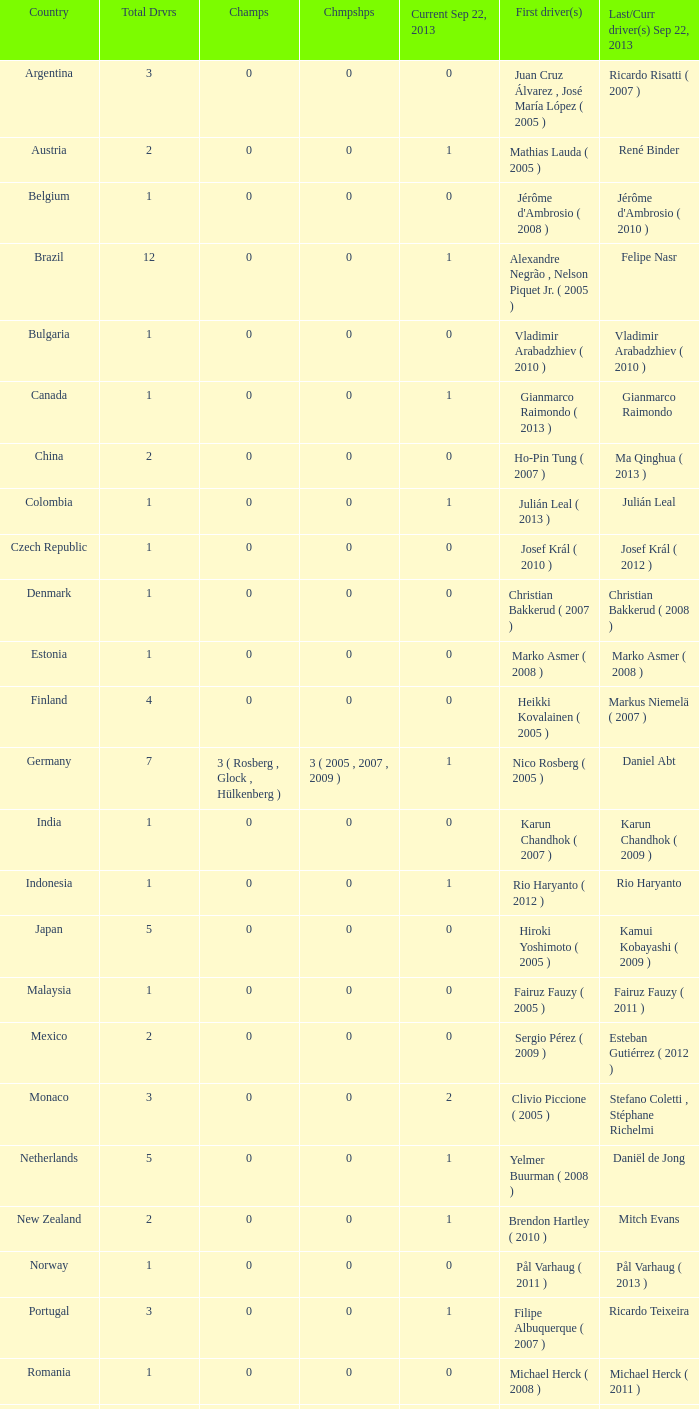Can you parse all the data within this table? {'header': ['Country', 'Total Drvrs', 'Champs', 'Chmpshps', 'Current Sep 22, 2013', 'First driver(s)', 'Last/Curr driver(s) Sep 22, 2013'], 'rows': [['Argentina', '3', '0', '0', '0', 'Juan Cruz Álvarez , José María López ( 2005 )', 'Ricardo Risatti ( 2007 )'], ['Austria', '2', '0', '0', '1', 'Mathias Lauda ( 2005 )', 'René Binder'], ['Belgium', '1', '0', '0', '0', "Jérôme d'Ambrosio ( 2008 )", "Jérôme d'Ambrosio ( 2010 )"], ['Brazil', '12', '0', '0', '1', 'Alexandre Negrão , Nelson Piquet Jr. ( 2005 )', 'Felipe Nasr'], ['Bulgaria', '1', '0', '0', '0', 'Vladimir Arabadzhiev ( 2010 )', 'Vladimir Arabadzhiev ( 2010 )'], ['Canada', '1', '0', '0', '1', 'Gianmarco Raimondo ( 2013 )', 'Gianmarco Raimondo'], ['China', '2', '0', '0', '0', 'Ho-Pin Tung ( 2007 )', 'Ma Qinghua ( 2013 )'], ['Colombia', '1', '0', '0', '1', 'Julián Leal ( 2013 )', 'Julián Leal'], ['Czech Republic', '1', '0', '0', '0', 'Josef Král ( 2010 )', 'Josef Král ( 2012 )'], ['Denmark', '1', '0', '0', '0', 'Christian Bakkerud ( 2007 )', 'Christian Bakkerud ( 2008 )'], ['Estonia', '1', '0', '0', '0', 'Marko Asmer ( 2008 )', 'Marko Asmer ( 2008 )'], ['Finland', '4', '0', '0', '0', 'Heikki Kovalainen ( 2005 )', 'Markus Niemelä ( 2007 )'], ['Germany', '7', '3 ( Rosberg , Glock , Hülkenberg )', '3 ( 2005 , 2007 , 2009 )', '1', 'Nico Rosberg ( 2005 )', 'Daniel Abt'], ['India', '1', '0', '0', '0', 'Karun Chandhok ( 2007 )', 'Karun Chandhok ( 2009 )'], ['Indonesia', '1', '0', '0', '1', 'Rio Haryanto ( 2012 )', 'Rio Haryanto'], ['Japan', '5', '0', '0', '0', 'Hiroki Yoshimoto ( 2005 )', 'Kamui Kobayashi ( 2009 )'], ['Malaysia', '1', '0', '0', '0', 'Fairuz Fauzy ( 2005 )', 'Fairuz Fauzy ( 2011 )'], ['Mexico', '2', '0', '0', '0', 'Sergio Pérez ( 2009 )', 'Esteban Gutiérrez ( 2012 )'], ['Monaco', '3', '0', '0', '2', 'Clivio Piccione ( 2005 )', 'Stefano Coletti , Stéphane Richelmi'], ['Netherlands', '5', '0', '0', '1', 'Yelmer Buurman ( 2008 )', 'Daniël de Jong'], ['New Zealand', '2', '0', '0', '1', 'Brendon Hartley ( 2010 )', 'Mitch Evans'], ['Norway', '1', '0', '0', '0', 'Pål Varhaug ( 2011 )', 'Pål Varhaug ( 2013 )'], ['Portugal', '3', '0', '0', '1', 'Filipe Albuquerque ( 2007 )', 'Ricardo Teixeira'], ['Romania', '1', '0', '0', '0', 'Michael Herck ( 2008 )', 'Michael Herck ( 2011 )'], ['Russia', '2', '0', '0', '0', 'Vitaly Petrov ( 2006 )', 'Mikhail Aleshin ( 2011 )'], ['Serbia', '1', '0', '0', '0', 'Miloš Pavlović ( 2008 )', 'Miloš Pavlović ( 2008 )'], ['South Africa', '1', '0', '0', '0', 'Adrian Zaugg ( 2007 )', 'Adrian Zaugg ( 2010 )'], ['Spain', '10', '0', '0', '2', 'Borja García , Sergio Hernández ( 2005 )', 'Sergio Canamasas , Dani Clos'], ['Sweden', '1', '0', '0', '1', 'Marcus Ericsson ( 2010 )', 'Marcus Ericsson'], ['Switzerland', '5', '0', '0', '2', 'Neel Jani ( 2005 )', 'Fabio Leimer , Simon Trummer'], ['Turkey', '2', '0', '0', '0', 'Can Artam ( 2005 )', 'Jason Tahincioglu ( 2007 )'], ['United Arab Emirates', '1', '0', '0', '0', 'Andreas Zuber ( 2006 )', 'Andreas Zuber ( 2009 )'], ['United States', '4', '0', '0', '2', 'Scott Speed ( 2005 )', 'Jake Rosenzweig , Alexander Rossi']]} How many champions were there when the last driver was Gianmarco Raimondo? 0.0. 